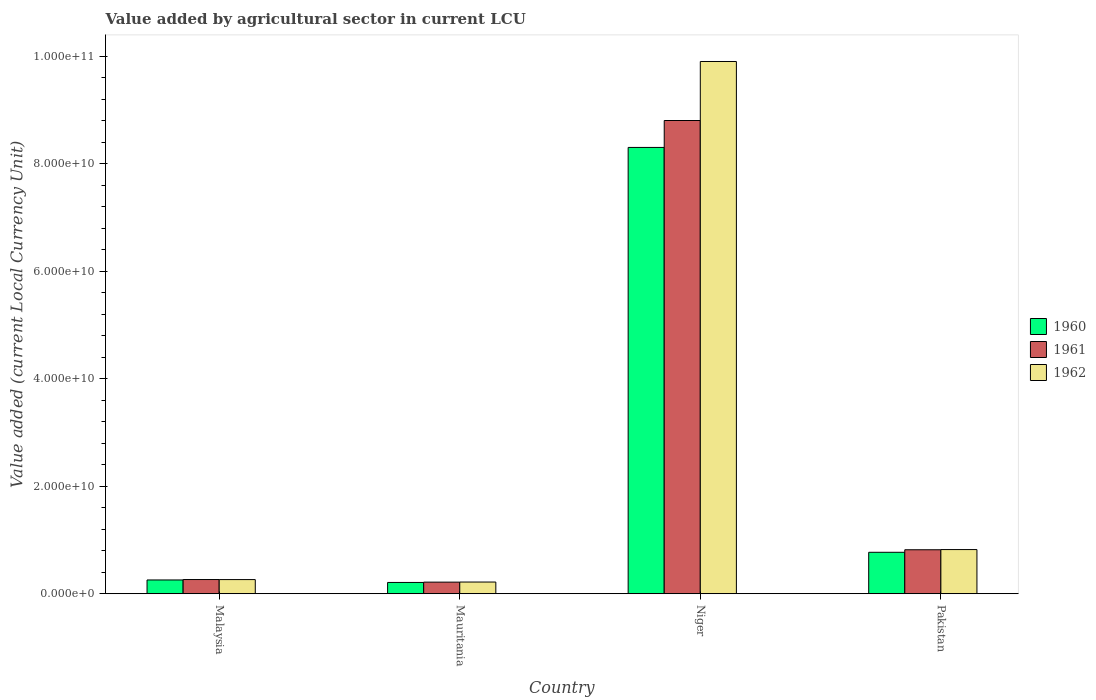How many different coloured bars are there?
Provide a succinct answer. 3. How many groups of bars are there?
Your answer should be very brief. 4. Are the number of bars per tick equal to the number of legend labels?
Offer a terse response. Yes. How many bars are there on the 3rd tick from the left?
Provide a succinct answer. 3. How many bars are there on the 3rd tick from the right?
Offer a terse response. 3. What is the label of the 2nd group of bars from the left?
Your answer should be compact. Mauritania. What is the value added by agricultural sector in 1962 in Niger?
Offer a very short reply. 9.90e+1. Across all countries, what is the maximum value added by agricultural sector in 1960?
Your answer should be compact. 8.30e+1. Across all countries, what is the minimum value added by agricultural sector in 1961?
Offer a very short reply. 2.16e+09. In which country was the value added by agricultural sector in 1960 maximum?
Your answer should be compact. Niger. In which country was the value added by agricultural sector in 1962 minimum?
Make the answer very short. Mauritania. What is the total value added by agricultural sector in 1961 in the graph?
Ensure brevity in your answer.  1.01e+11. What is the difference between the value added by agricultural sector in 1962 in Malaysia and that in Mauritania?
Give a very brief answer. 4.54e+08. What is the difference between the value added by agricultural sector in 1960 in Malaysia and the value added by agricultural sector in 1962 in Mauritania?
Offer a very short reply. 3.86e+08. What is the average value added by agricultural sector in 1960 per country?
Provide a short and direct response. 2.39e+1. What is the difference between the value added by agricultural sector of/in 1960 and value added by agricultural sector of/in 1962 in Pakistan?
Give a very brief answer. -5.05e+08. What is the ratio of the value added by agricultural sector in 1961 in Malaysia to that in Mauritania?
Your answer should be compact. 1.22. Is the value added by agricultural sector in 1961 in Niger less than that in Pakistan?
Your answer should be compact. No. Is the difference between the value added by agricultural sector in 1960 in Niger and Pakistan greater than the difference between the value added by agricultural sector in 1962 in Niger and Pakistan?
Ensure brevity in your answer.  No. What is the difference between the highest and the second highest value added by agricultural sector in 1962?
Offer a very short reply. 9.08e+1. What is the difference between the highest and the lowest value added by agricultural sector in 1961?
Give a very brief answer. 8.59e+1. In how many countries, is the value added by agricultural sector in 1960 greater than the average value added by agricultural sector in 1960 taken over all countries?
Offer a very short reply. 1. How many bars are there?
Your answer should be very brief. 12. Are all the bars in the graph horizontal?
Give a very brief answer. No. How many countries are there in the graph?
Give a very brief answer. 4. What is the difference between two consecutive major ticks on the Y-axis?
Provide a short and direct response. 2.00e+1. Are the values on the major ticks of Y-axis written in scientific E-notation?
Ensure brevity in your answer.  Yes. Does the graph contain any zero values?
Make the answer very short. No. Does the graph contain grids?
Your answer should be compact. No. Where does the legend appear in the graph?
Make the answer very short. Center right. What is the title of the graph?
Offer a very short reply. Value added by agricultural sector in current LCU. Does "1969" appear as one of the legend labels in the graph?
Your response must be concise. No. What is the label or title of the X-axis?
Offer a very short reply. Country. What is the label or title of the Y-axis?
Your answer should be compact. Value added (current Local Currency Unit). What is the Value added (current Local Currency Unit) in 1960 in Malaysia?
Keep it short and to the point. 2.56e+09. What is the Value added (current Local Currency Unit) in 1961 in Malaysia?
Offer a terse response. 2.64e+09. What is the Value added (current Local Currency Unit) of 1962 in Malaysia?
Make the answer very short. 2.63e+09. What is the Value added (current Local Currency Unit) in 1960 in Mauritania?
Provide a short and direct response. 2.10e+09. What is the Value added (current Local Currency Unit) in 1961 in Mauritania?
Ensure brevity in your answer.  2.16e+09. What is the Value added (current Local Currency Unit) of 1962 in Mauritania?
Keep it short and to the point. 2.18e+09. What is the Value added (current Local Currency Unit) in 1960 in Niger?
Provide a succinct answer. 8.30e+1. What is the Value added (current Local Currency Unit) of 1961 in Niger?
Offer a terse response. 8.80e+1. What is the Value added (current Local Currency Unit) in 1962 in Niger?
Make the answer very short. 9.90e+1. What is the Value added (current Local Currency Unit) in 1960 in Pakistan?
Your answer should be compact. 7.71e+09. What is the Value added (current Local Currency Unit) of 1961 in Pakistan?
Keep it short and to the point. 8.18e+09. What is the Value added (current Local Currency Unit) of 1962 in Pakistan?
Make the answer very short. 8.22e+09. Across all countries, what is the maximum Value added (current Local Currency Unit) of 1960?
Your answer should be compact. 8.30e+1. Across all countries, what is the maximum Value added (current Local Currency Unit) in 1961?
Make the answer very short. 8.80e+1. Across all countries, what is the maximum Value added (current Local Currency Unit) of 1962?
Your answer should be very brief. 9.90e+1. Across all countries, what is the minimum Value added (current Local Currency Unit) of 1960?
Your answer should be very brief. 2.10e+09. Across all countries, what is the minimum Value added (current Local Currency Unit) of 1961?
Keep it short and to the point. 2.16e+09. Across all countries, what is the minimum Value added (current Local Currency Unit) of 1962?
Keep it short and to the point. 2.18e+09. What is the total Value added (current Local Currency Unit) of 1960 in the graph?
Your answer should be very brief. 9.54e+1. What is the total Value added (current Local Currency Unit) of 1961 in the graph?
Give a very brief answer. 1.01e+11. What is the total Value added (current Local Currency Unit) in 1962 in the graph?
Your answer should be very brief. 1.12e+11. What is the difference between the Value added (current Local Currency Unit) of 1960 in Malaysia and that in Mauritania?
Provide a short and direct response. 4.61e+08. What is the difference between the Value added (current Local Currency Unit) in 1961 in Malaysia and that in Mauritania?
Ensure brevity in your answer.  4.82e+08. What is the difference between the Value added (current Local Currency Unit) in 1962 in Malaysia and that in Mauritania?
Ensure brevity in your answer.  4.54e+08. What is the difference between the Value added (current Local Currency Unit) in 1960 in Malaysia and that in Niger?
Your answer should be very brief. -8.05e+1. What is the difference between the Value added (current Local Currency Unit) in 1961 in Malaysia and that in Niger?
Offer a very short reply. -8.54e+1. What is the difference between the Value added (current Local Currency Unit) in 1962 in Malaysia and that in Niger?
Offer a very short reply. -9.64e+1. What is the difference between the Value added (current Local Currency Unit) in 1960 in Malaysia and that in Pakistan?
Offer a very short reply. -5.15e+09. What is the difference between the Value added (current Local Currency Unit) of 1961 in Malaysia and that in Pakistan?
Offer a very short reply. -5.54e+09. What is the difference between the Value added (current Local Currency Unit) of 1962 in Malaysia and that in Pakistan?
Keep it short and to the point. -5.58e+09. What is the difference between the Value added (current Local Currency Unit) of 1960 in Mauritania and that in Niger?
Offer a very short reply. -8.09e+1. What is the difference between the Value added (current Local Currency Unit) of 1961 in Mauritania and that in Niger?
Offer a very short reply. -8.59e+1. What is the difference between the Value added (current Local Currency Unit) in 1962 in Mauritania and that in Niger?
Your answer should be compact. -9.68e+1. What is the difference between the Value added (current Local Currency Unit) in 1960 in Mauritania and that in Pakistan?
Provide a short and direct response. -5.61e+09. What is the difference between the Value added (current Local Currency Unit) of 1961 in Mauritania and that in Pakistan?
Your answer should be very brief. -6.02e+09. What is the difference between the Value added (current Local Currency Unit) of 1962 in Mauritania and that in Pakistan?
Give a very brief answer. -6.04e+09. What is the difference between the Value added (current Local Currency Unit) in 1960 in Niger and that in Pakistan?
Keep it short and to the point. 7.53e+1. What is the difference between the Value added (current Local Currency Unit) in 1961 in Niger and that in Pakistan?
Offer a terse response. 7.98e+1. What is the difference between the Value added (current Local Currency Unit) of 1962 in Niger and that in Pakistan?
Your answer should be compact. 9.08e+1. What is the difference between the Value added (current Local Currency Unit) of 1960 in Malaysia and the Value added (current Local Currency Unit) of 1961 in Mauritania?
Provide a succinct answer. 4.04e+08. What is the difference between the Value added (current Local Currency Unit) of 1960 in Malaysia and the Value added (current Local Currency Unit) of 1962 in Mauritania?
Provide a short and direct response. 3.86e+08. What is the difference between the Value added (current Local Currency Unit) in 1961 in Malaysia and the Value added (current Local Currency Unit) in 1962 in Mauritania?
Offer a terse response. 4.63e+08. What is the difference between the Value added (current Local Currency Unit) of 1960 in Malaysia and the Value added (current Local Currency Unit) of 1961 in Niger?
Your answer should be very brief. -8.55e+1. What is the difference between the Value added (current Local Currency Unit) in 1960 in Malaysia and the Value added (current Local Currency Unit) in 1962 in Niger?
Your answer should be very brief. -9.64e+1. What is the difference between the Value added (current Local Currency Unit) in 1961 in Malaysia and the Value added (current Local Currency Unit) in 1962 in Niger?
Give a very brief answer. -9.64e+1. What is the difference between the Value added (current Local Currency Unit) of 1960 in Malaysia and the Value added (current Local Currency Unit) of 1961 in Pakistan?
Keep it short and to the point. -5.62e+09. What is the difference between the Value added (current Local Currency Unit) of 1960 in Malaysia and the Value added (current Local Currency Unit) of 1962 in Pakistan?
Your answer should be compact. -5.65e+09. What is the difference between the Value added (current Local Currency Unit) of 1961 in Malaysia and the Value added (current Local Currency Unit) of 1962 in Pakistan?
Give a very brief answer. -5.57e+09. What is the difference between the Value added (current Local Currency Unit) of 1960 in Mauritania and the Value added (current Local Currency Unit) of 1961 in Niger?
Offer a terse response. -8.59e+1. What is the difference between the Value added (current Local Currency Unit) of 1960 in Mauritania and the Value added (current Local Currency Unit) of 1962 in Niger?
Offer a terse response. -9.69e+1. What is the difference between the Value added (current Local Currency Unit) in 1961 in Mauritania and the Value added (current Local Currency Unit) in 1962 in Niger?
Make the answer very short. -9.69e+1. What is the difference between the Value added (current Local Currency Unit) in 1960 in Mauritania and the Value added (current Local Currency Unit) in 1961 in Pakistan?
Keep it short and to the point. -6.08e+09. What is the difference between the Value added (current Local Currency Unit) of 1960 in Mauritania and the Value added (current Local Currency Unit) of 1962 in Pakistan?
Your answer should be very brief. -6.11e+09. What is the difference between the Value added (current Local Currency Unit) in 1961 in Mauritania and the Value added (current Local Currency Unit) in 1962 in Pakistan?
Provide a succinct answer. -6.06e+09. What is the difference between the Value added (current Local Currency Unit) in 1960 in Niger and the Value added (current Local Currency Unit) in 1961 in Pakistan?
Your answer should be very brief. 7.48e+1. What is the difference between the Value added (current Local Currency Unit) in 1960 in Niger and the Value added (current Local Currency Unit) in 1962 in Pakistan?
Offer a very short reply. 7.48e+1. What is the difference between the Value added (current Local Currency Unit) in 1961 in Niger and the Value added (current Local Currency Unit) in 1962 in Pakistan?
Give a very brief answer. 7.98e+1. What is the average Value added (current Local Currency Unit) in 1960 per country?
Your answer should be very brief. 2.39e+1. What is the average Value added (current Local Currency Unit) of 1961 per country?
Give a very brief answer. 2.53e+1. What is the average Value added (current Local Currency Unit) in 1962 per country?
Your answer should be very brief. 2.80e+1. What is the difference between the Value added (current Local Currency Unit) in 1960 and Value added (current Local Currency Unit) in 1961 in Malaysia?
Offer a terse response. -7.78e+07. What is the difference between the Value added (current Local Currency Unit) in 1960 and Value added (current Local Currency Unit) in 1962 in Malaysia?
Your answer should be very brief. -6.83e+07. What is the difference between the Value added (current Local Currency Unit) in 1961 and Value added (current Local Currency Unit) in 1962 in Malaysia?
Your response must be concise. 9.46e+06. What is the difference between the Value added (current Local Currency Unit) in 1960 and Value added (current Local Currency Unit) in 1961 in Mauritania?
Your answer should be compact. -5.68e+07. What is the difference between the Value added (current Local Currency Unit) of 1960 and Value added (current Local Currency Unit) of 1962 in Mauritania?
Your answer should be compact. -7.58e+07. What is the difference between the Value added (current Local Currency Unit) of 1961 and Value added (current Local Currency Unit) of 1962 in Mauritania?
Your response must be concise. -1.89e+07. What is the difference between the Value added (current Local Currency Unit) of 1960 and Value added (current Local Currency Unit) of 1961 in Niger?
Offer a very short reply. -5.01e+09. What is the difference between the Value added (current Local Currency Unit) in 1960 and Value added (current Local Currency Unit) in 1962 in Niger?
Give a very brief answer. -1.60e+1. What is the difference between the Value added (current Local Currency Unit) in 1961 and Value added (current Local Currency Unit) in 1962 in Niger?
Make the answer very short. -1.10e+1. What is the difference between the Value added (current Local Currency Unit) of 1960 and Value added (current Local Currency Unit) of 1961 in Pakistan?
Keep it short and to the point. -4.73e+08. What is the difference between the Value added (current Local Currency Unit) of 1960 and Value added (current Local Currency Unit) of 1962 in Pakistan?
Your response must be concise. -5.05e+08. What is the difference between the Value added (current Local Currency Unit) in 1961 and Value added (current Local Currency Unit) in 1962 in Pakistan?
Ensure brevity in your answer.  -3.20e+07. What is the ratio of the Value added (current Local Currency Unit) of 1960 in Malaysia to that in Mauritania?
Your answer should be very brief. 1.22. What is the ratio of the Value added (current Local Currency Unit) of 1961 in Malaysia to that in Mauritania?
Provide a short and direct response. 1.22. What is the ratio of the Value added (current Local Currency Unit) of 1962 in Malaysia to that in Mauritania?
Give a very brief answer. 1.21. What is the ratio of the Value added (current Local Currency Unit) in 1960 in Malaysia to that in Niger?
Offer a terse response. 0.03. What is the ratio of the Value added (current Local Currency Unit) of 1962 in Malaysia to that in Niger?
Keep it short and to the point. 0.03. What is the ratio of the Value added (current Local Currency Unit) in 1960 in Malaysia to that in Pakistan?
Make the answer very short. 0.33. What is the ratio of the Value added (current Local Currency Unit) in 1961 in Malaysia to that in Pakistan?
Your response must be concise. 0.32. What is the ratio of the Value added (current Local Currency Unit) in 1962 in Malaysia to that in Pakistan?
Keep it short and to the point. 0.32. What is the ratio of the Value added (current Local Currency Unit) of 1960 in Mauritania to that in Niger?
Offer a terse response. 0.03. What is the ratio of the Value added (current Local Currency Unit) of 1961 in Mauritania to that in Niger?
Provide a succinct answer. 0.02. What is the ratio of the Value added (current Local Currency Unit) in 1962 in Mauritania to that in Niger?
Your answer should be very brief. 0.02. What is the ratio of the Value added (current Local Currency Unit) of 1960 in Mauritania to that in Pakistan?
Your response must be concise. 0.27. What is the ratio of the Value added (current Local Currency Unit) of 1961 in Mauritania to that in Pakistan?
Ensure brevity in your answer.  0.26. What is the ratio of the Value added (current Local Currency Unit) of 1962 in Mauritania to that in Pakistan?
Offer a very short reply. 0.27. What is the ratio of the Value added (current Local Currency Unit) in 1960 in Niger to that in Pakistan?
Provide a short and direct response. 10.77. What is the ratio of the Value added (current Local Currency Unit) of 1961 in Niger to that in Pakistan?
Offer a very short reply. 10.76. What is the ratio of the Value added (current Local Currency Unit) of 1962 in Niger to that in Pakistan?
Ensure brevity in your answer.  12.05. What is the difference between the highest and the second highest Value added (current Local Currency Unit) in 1960?
Provide a short and direct response. 7.53e+1. What is the difference between the highest and the second highest Value added (current Local Currency Unit) of 1961?
Offer a very short reply. 7.98e+1. What is the difference between the highest and the second highest Value added (current Local Currency Unit) in 1962?
Your answer should be compact. 9.08e+1. What is the difference between the highest and the lowest Value added (current Local Currency Unit) in 1960?
Keep it short and to the point. 8.09e+1. What is the difference between the highest and the lowest Value added (current Local Currency Unit) in 1961?
Make the answer very short. 8.59e+1. What is the difference between the highest and the lowest Value added (current Local Currency Unit) in 1962?
Offer a very short reply. 9.68e+1. 